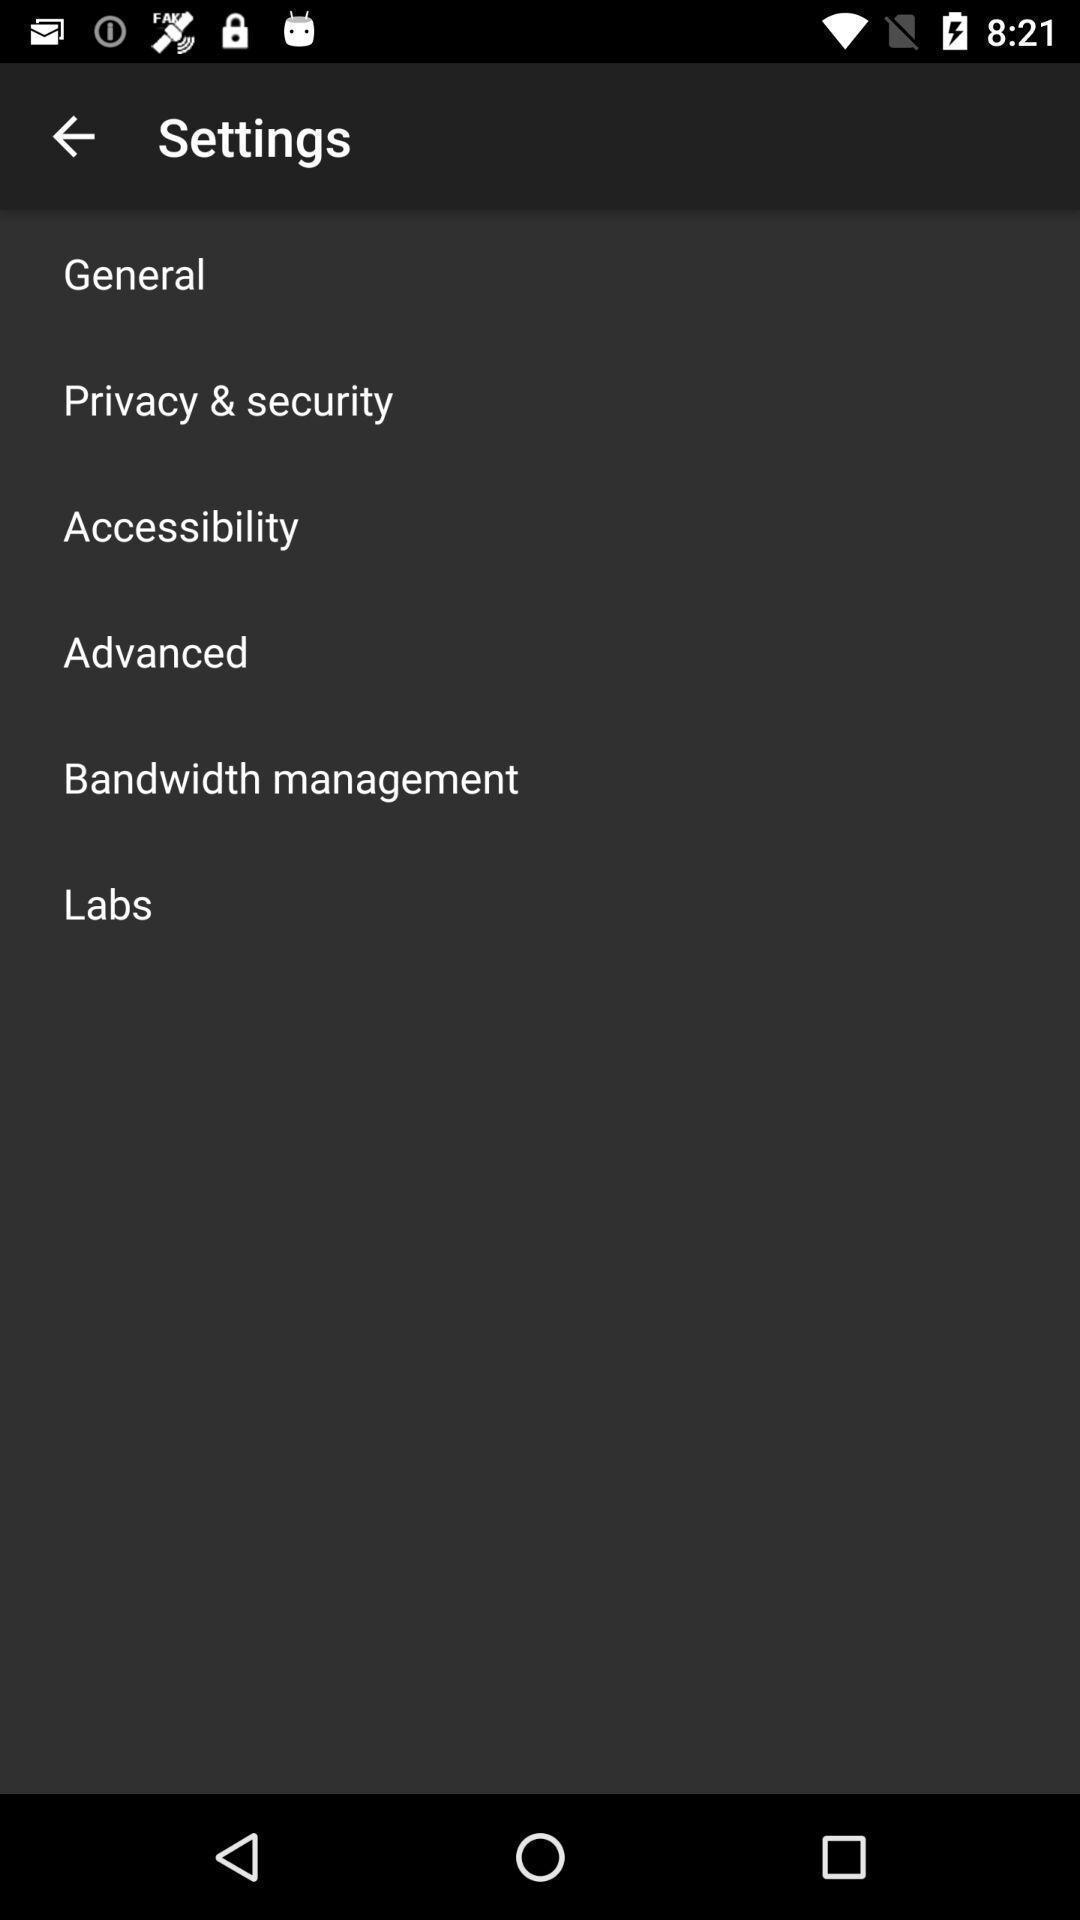Provide a description of this screenshot. Settings page with multiple options. 